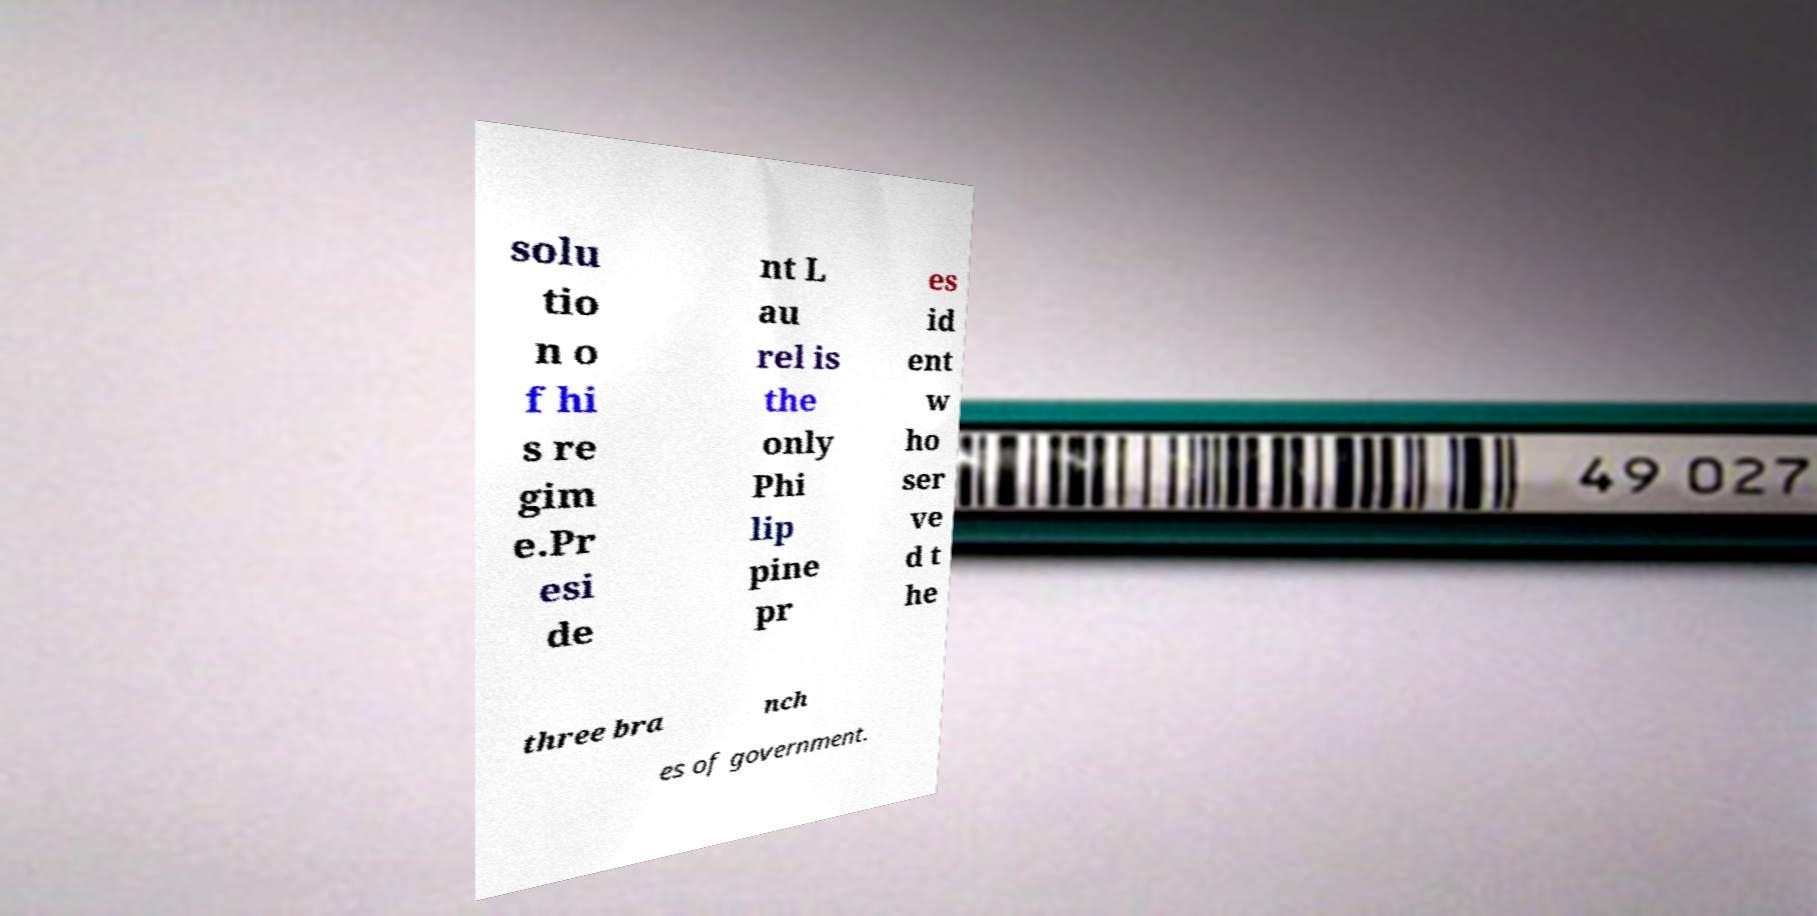Could you extract and type out the text from this image? solu tio n o f hi s re gim e.Pr esi de nt L au rel is the only Phi lip pine pr es id ent w ho ser ve d t he three bra nch es of government. 